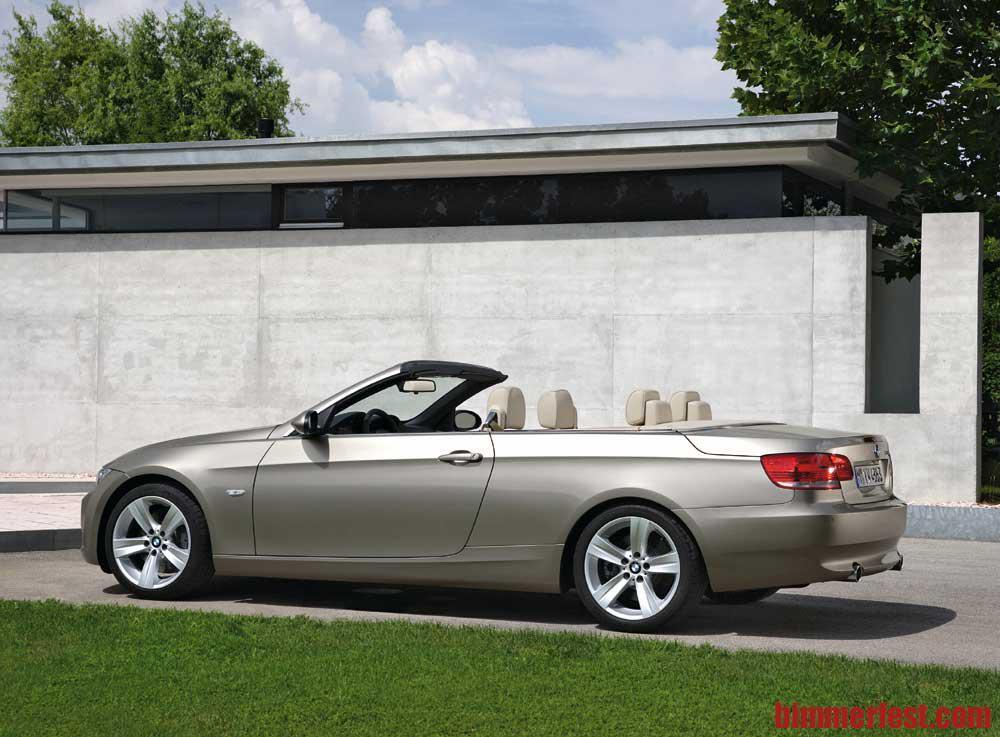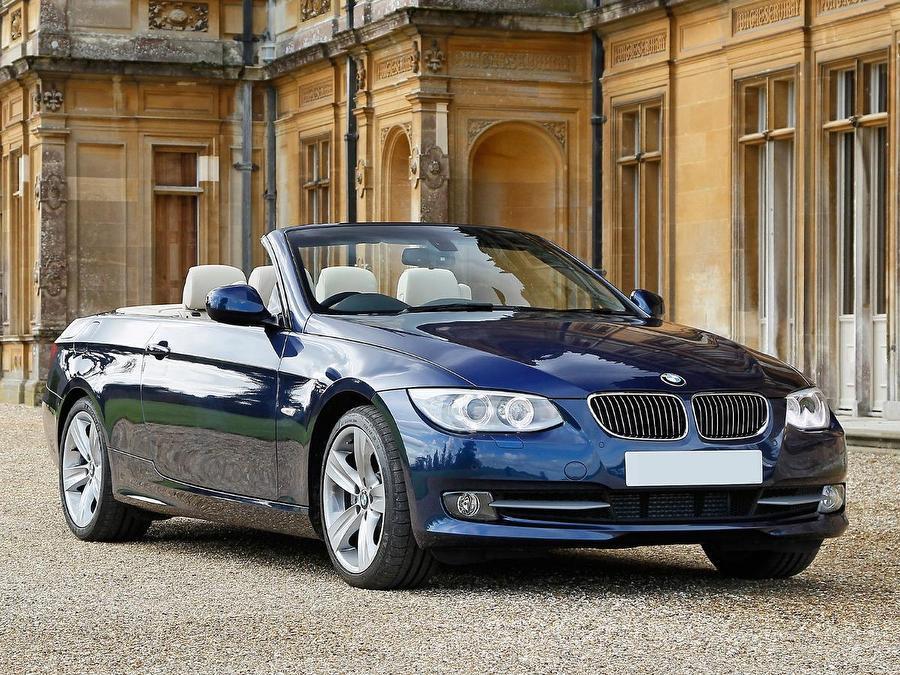The first image is the image on the left, the second image is the image on the right. Given the left and right images, does the statement "Right image contains one blue car, which has a hard top." hold true? Answer yes or no. No. The first image is the image on the left, the second image is the image on the right. Analyze the images presented: Is the assertion "In the image on the right, there is a blue car without the top down" valid? Answer yes or no. No. 